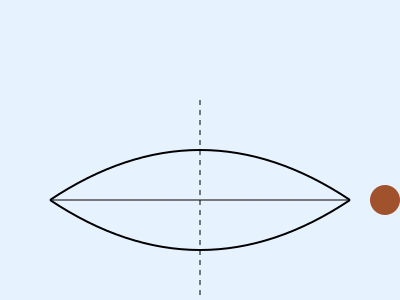In the cross-section of a traditional outrigger canoe shown above, what is the geometric shape formed by the main hull, and how does it contribute to the canoe's stability and performance in the water? To answer this question, let's analyze the cross-section step-by-step:

1. The main hull of the outrigger canoe is represented by the curved shape in the center of the diagram.

2. The geometric shape formed by the main hull is a lens shape, which can be described mathematically as the intersection of two circular arcs.

3. This lens shape is crucial for the canoe's performance:
   a) The curved bottom reduces water resistance, allowing the canoe to move efficiently through the water.
   b) The symmetrical design helps maintain balance and stability in calm waters.

4. The lens shape also contributes to the canoe's stability:
   a) The wider middle section provides buoyancy and helps prevent tipping.
   b) The tapered ends reduce drag and improve maneuverability.

5. The outrigger (represented by the circle on the right) further enhances stability by providing additional support and counterbalance, especially in rougher waters.

6. The lens shape, combined with the outrigger, allows the canoe to be both stable and fast, making it ideal for navigating various ocean conditions encountered in island environments.
Answer: Lens shape 